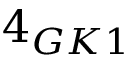Convert formula to latex. <formula><loc_0><loc_0><loc_500><loc_500>4 _ { G K 1 }</formula> 